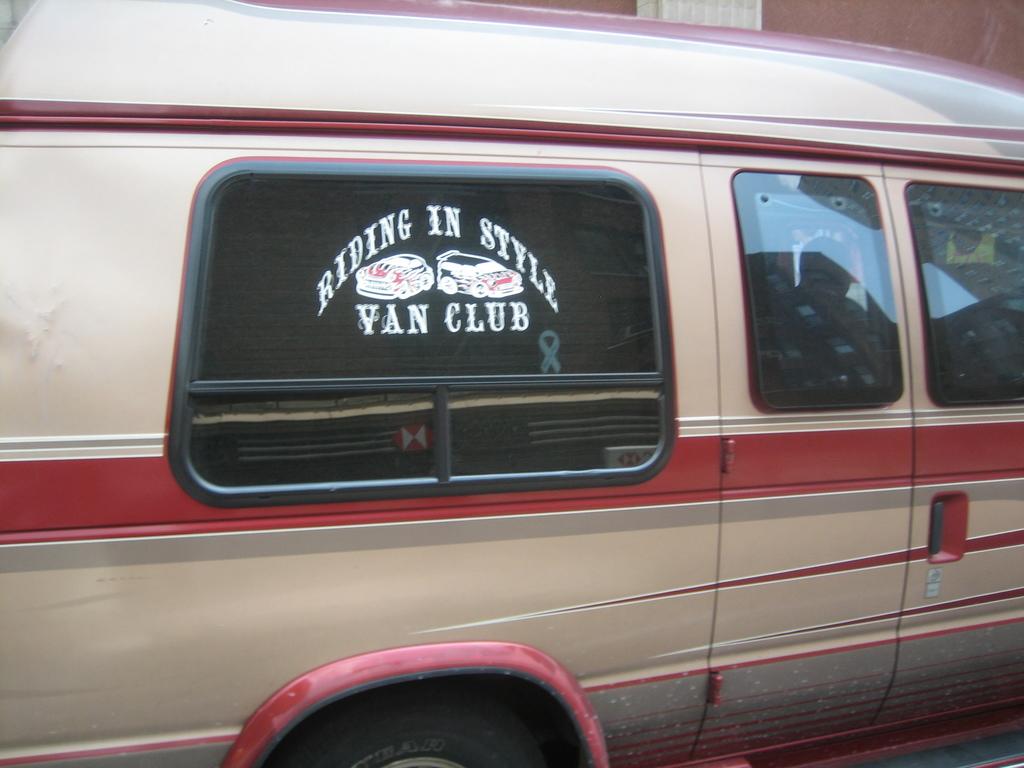When you ride in the van how are you riding?
Offer a terse response. In style. What is written on the van's window?
Keep it short and to the point. Riding in style van club. 